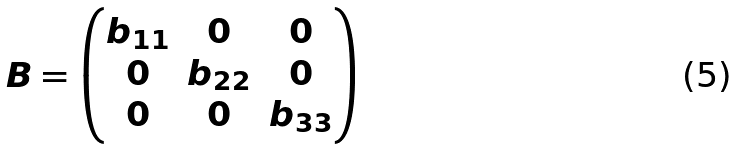<formula> <loc_0><loc_0><loc_500><loc_500>B = \begin{pmatrix} b _ { 1 1 } & 0 & 0 \\ 0 & b _ { 2 2 } & 0 \\ 0 & 0 & b _ { 3 3 } \end{pmatrix}</formula> 